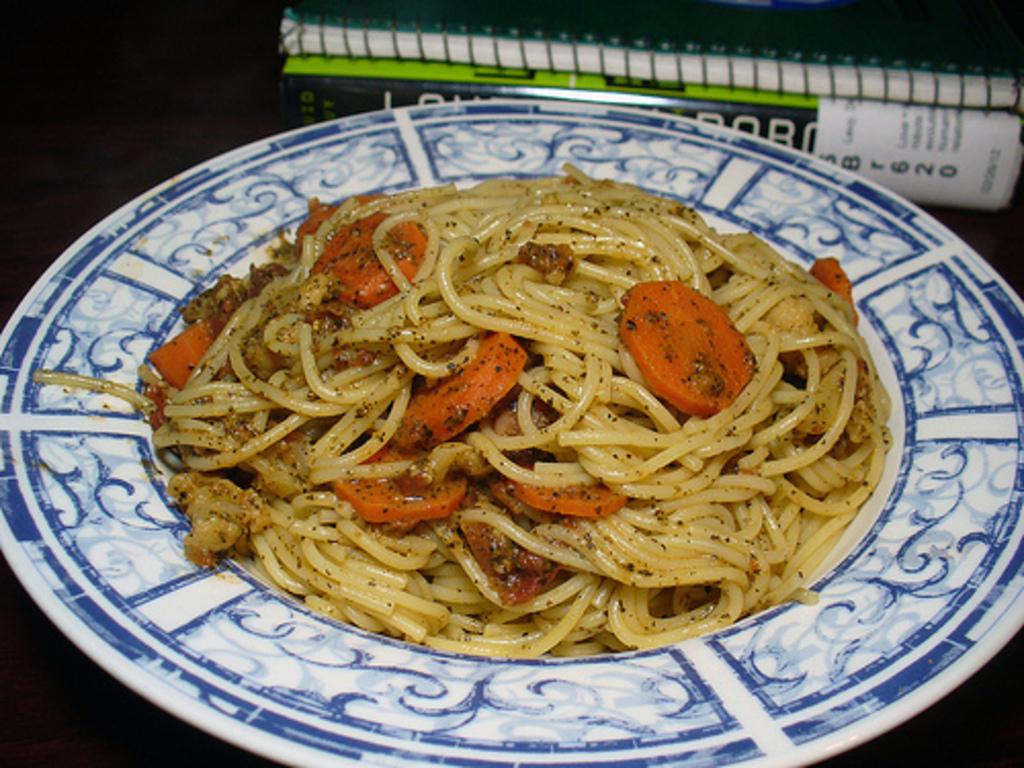What type of food is on the plate in the image? There are noodles on a plate in the image. Are there any vegetables on the plate? Yes, there are carrot pieces on the plate in the image. Where is the plate located in the image? The plate is present on a table in the image. What else can be seen on the table? There are books on the table in the image. What type of creature is hosting the party on the table in the image? There is no creature present in the image, nor is there any indication of a party. 